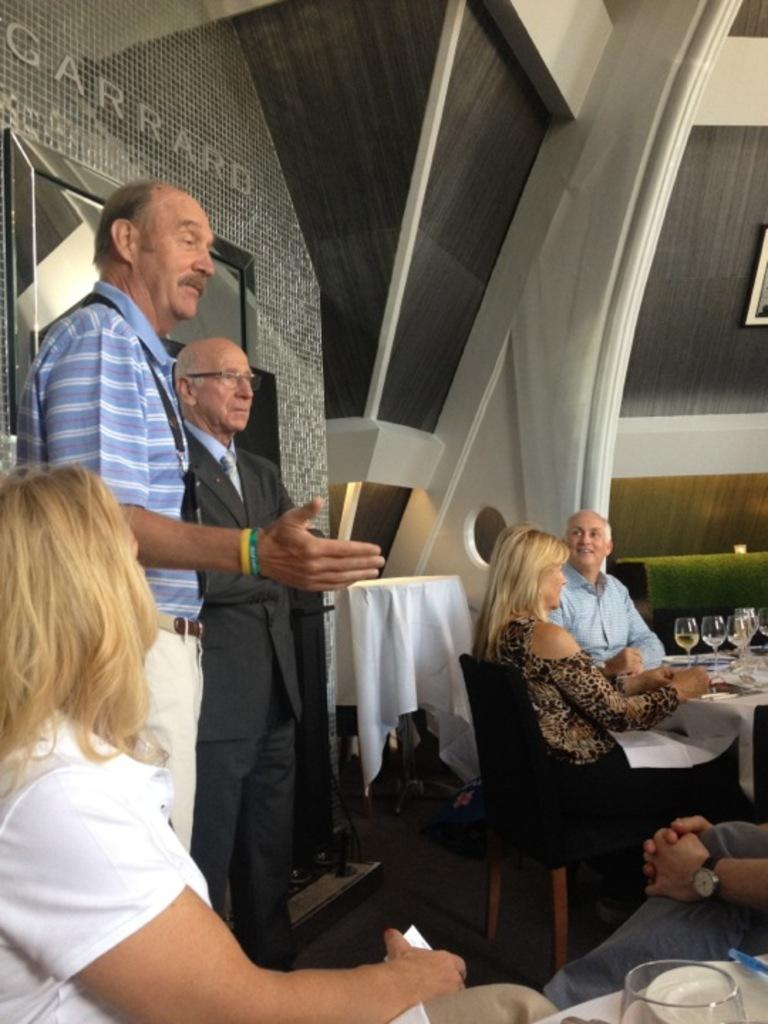How many men are present in the image? There are two men standing in the image. What are the men doing in the image? The men are explaining something to people sitting on chairs. What can be seen in the background of the image? There is a building in the background of the image. What is on the table in the image? There is a table with cloth on it in the image. Can you see any pins on the seashore in the image? There is no seashore or pins present in the image. What type of office furniture can be seen in the image? The image does not show any office furniture, as it features two men explaining something to people sitting on chairs. 